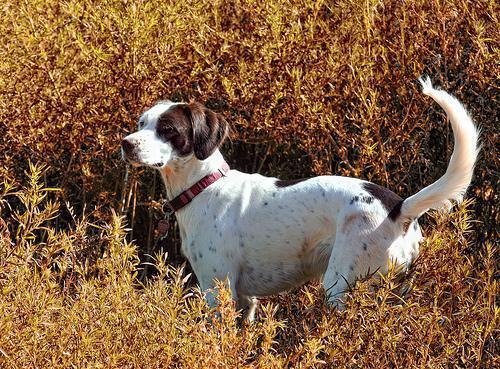How many dogs are in the picture?
Give a very brief answer. 1. 